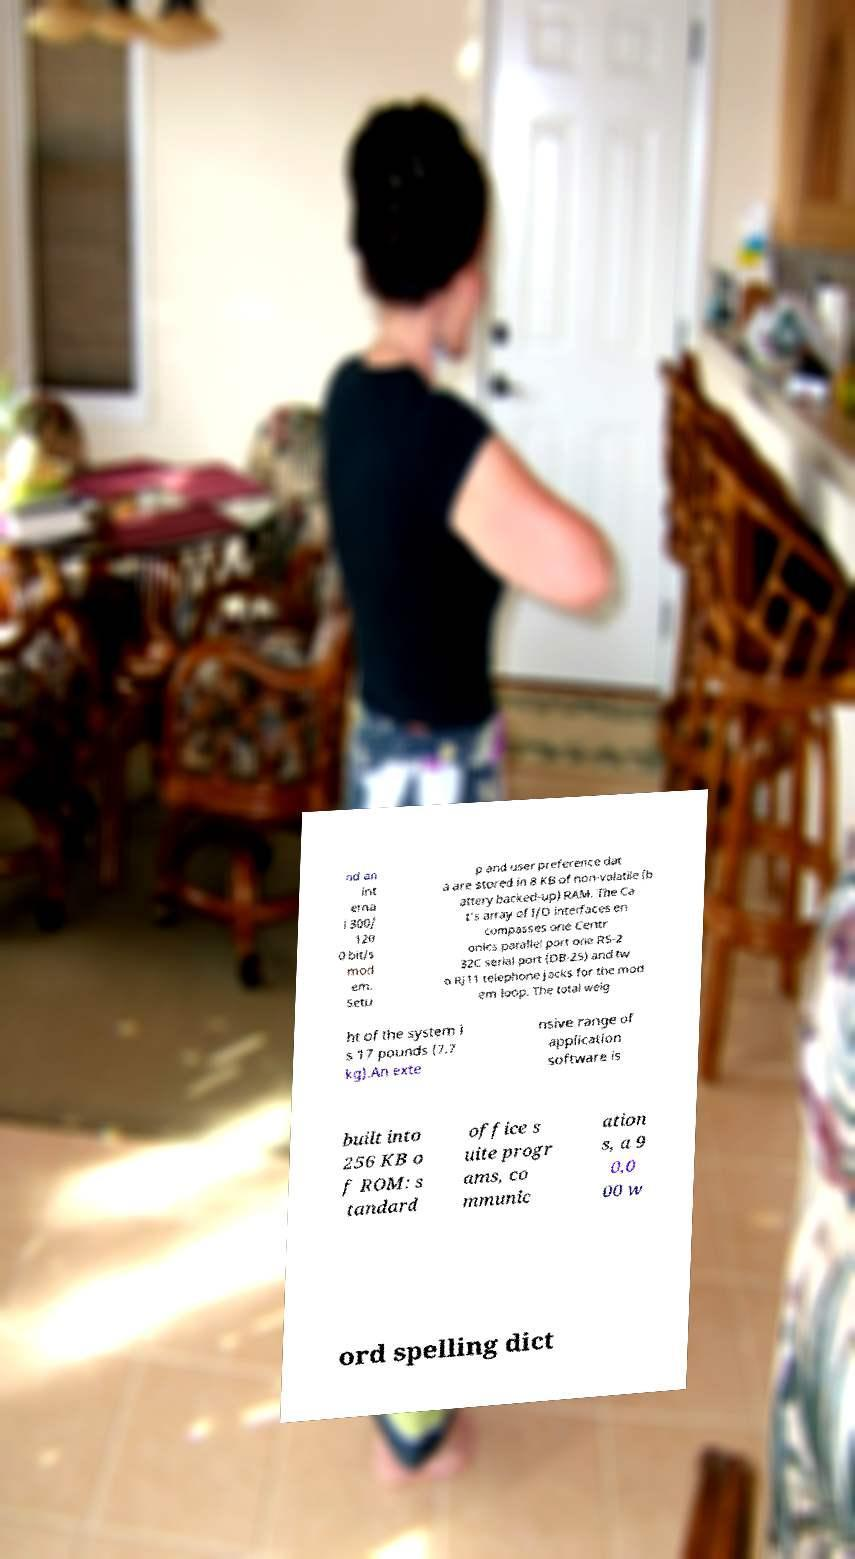I need the written content from this picture converted into text. Can you do that? nd an int erna l 300/ 120 0 bit/s mod em. Setu p and user preference dat a are stored in 8 KB of non-volatile (b attery backed-up) RAM. The Ca t's array of I/O interfaces en compasses one Centr onics parallel port one RS-2 32C serial port (DB-25) and tw o RJ11 telephone jacks for the mod em loop. The total weig ht of the system i s 17 pounds (7.7 kg).An exte nsive range of application software is built into 256 KB o f ROM: s tandard office s uite progr ams, co mmunic ation s, a 9 0,0 00 w ord spelling dict 